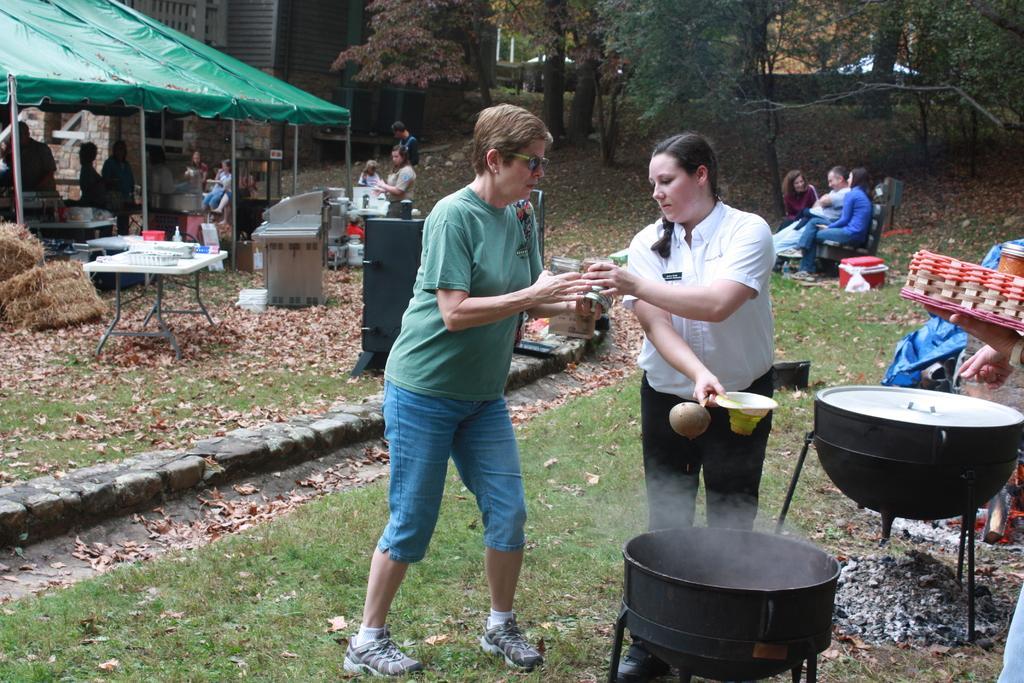Can you describe this image briefly? In this image we can see the people. We can also see the vessels, dried leaves, grass, table and also some other objects. We can also see the building and a tent for shelter. In the background we can see the trees and also the wall. 